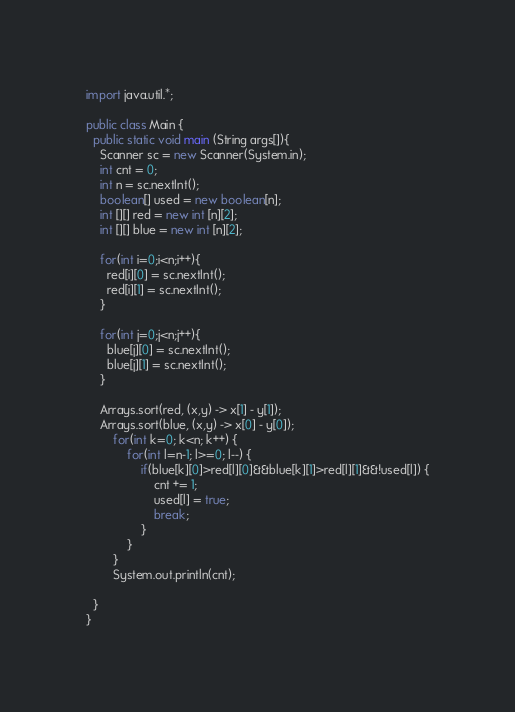<code> <loc_0><loc_0><loc_500><loc_500><_Java_>import java.util.*;

public class Main {
  public static void main (String args[]){
    Scanner sc = new Scanner(System.in);
    int cnt = 0;
	int n = sc.nextInt();
    boolean[] used = new boolean[n];
    int [][] red = new int [n][2];
    int [][] blue = new int [n][2];
    
    for(int i=0;i<n;i++){
      red[i][0] = sc.nextInt();
      red[i][1] = sc.nextInt();
    }
    
    for(int j=0;j<n;j++){
      blue[j][0] = sc.nextInt();
      blue[j][1] = sc.nextInt();
    }
    
    Arrays.sort(red, (x,y) -> x[1] - y[1]);
    Arrays.sort(blue, (x,y) -> x[0] - y[0]);
		for(int k=0; k<n; k++) {
			for(int l=n-1; l>=0; l--) {
				if(blue[k][0]>red[l][0]&&blue[k][1]>red[l][1]&&!used[l]) {
					cnt += 1;
					used[l] = true;
					break;
				}
			}
		}
		System.out.println(cnt);
    
  }
}</code> 